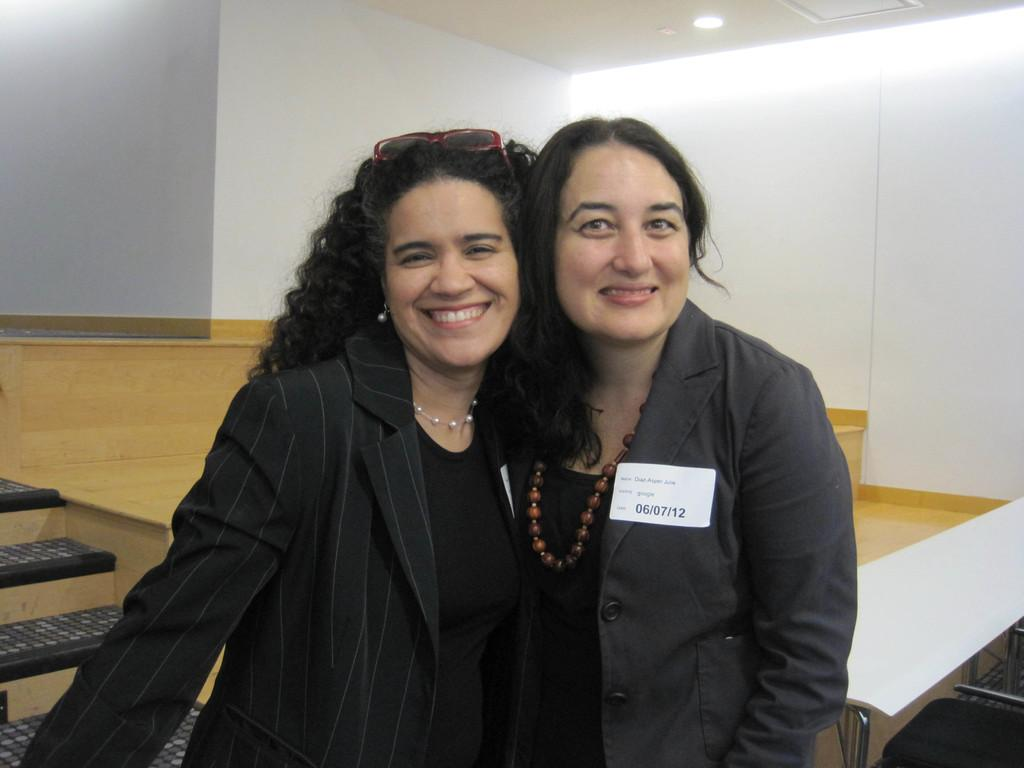How many people are in the image? There are two women in the image. What are the women doing in the image? The women are standing and smiling. What can be seen in the background of the image? There are white walls in the background of the image. Are there any cobwebs visible in the image? No, there are no cobwebs present in the image. What type of pie is being served by the women in the image? There is no pie visible in the image; the women are simply standing and smiling. 